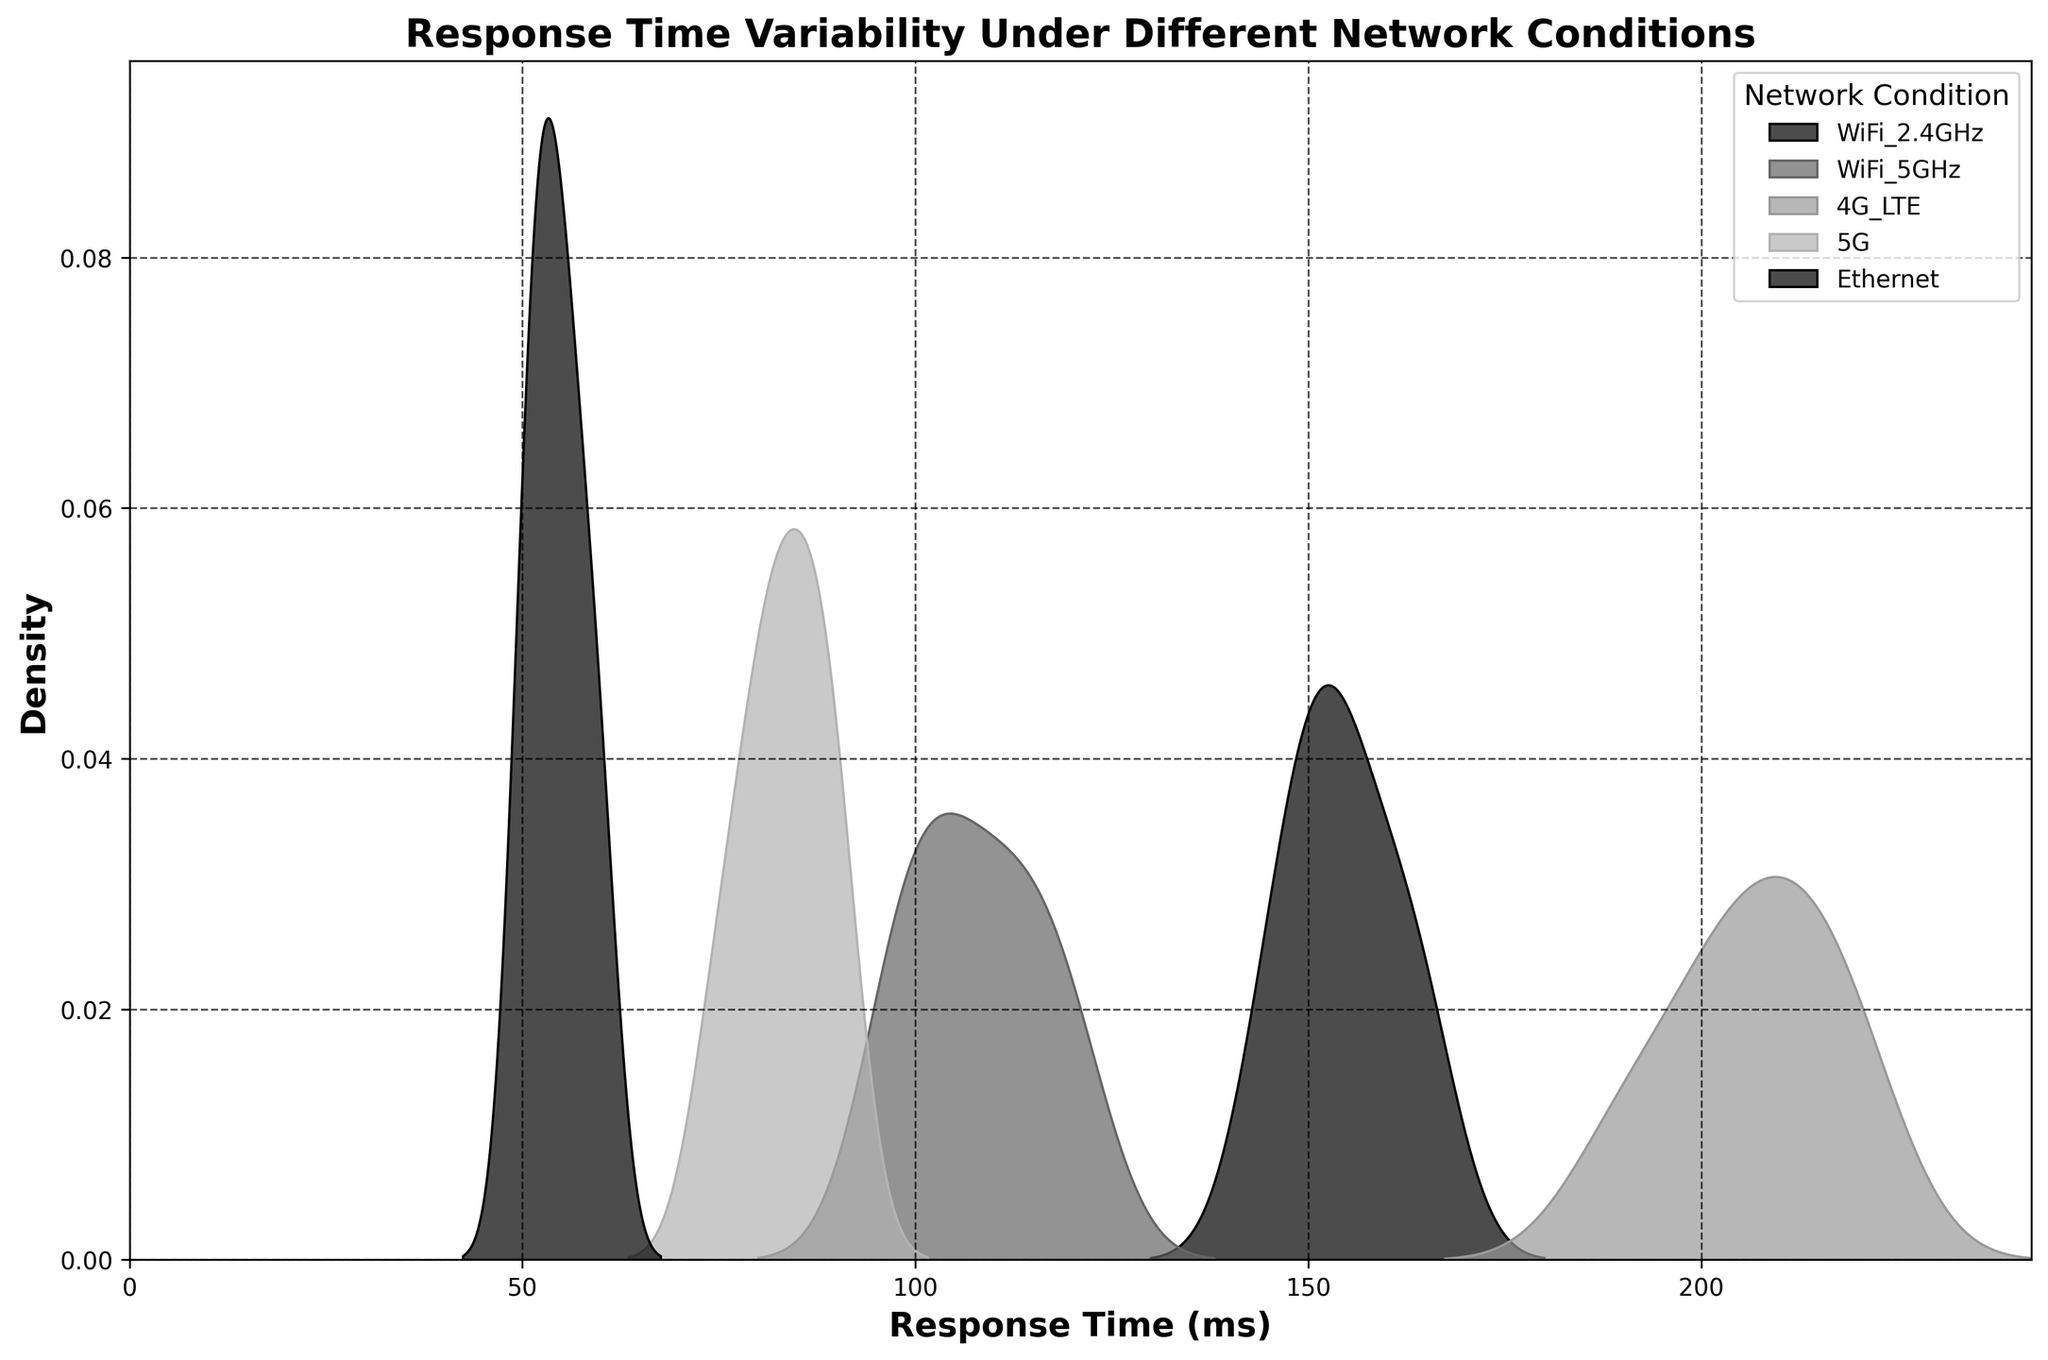What's the title of the figure? The title of the figure is located at the top, and it gives an overview of what the plot is about. By reading it, we learn that it is observing response time variability under different network conditions.
Answer: Response Time Variability Under Different Network Conditions What is the unit for the x-axis? The x-axis label indicates the unit of measure for response time, which is clearly stated in parentheses after the label name.
Answer: ms (milliseconds) Which network condition has the highest peak density? By observing the peaks of the density curves, you can identify that the highest peak density is depicted by the curve that reaches the highest value on the y-axis.
Answer: 5G What is the approximate range of response time values for Ethernet? Looking at the density curve for Ethernet, you identify the spread along the x-axis where this curve shows density. Ethernet has values around 50 to 60 ms.
Answer: 50 to 60 ms Is there any network condition with a response time density higher than 250 ms? Check the x-axis range and ensure none of the density lines extend beyond this value. All curves should be below this threshold based on the plot’s boundaries.
Answer: No Which network condition has the lowest variability in response times? The network condition with the narrowest peak (most concentrated) density curve has the lowest variability. This can be identified by observing which curve has the smallest spread.
Answer: Ethernet How many unique network conditions are compared in the plot? Count the number of unique labels in the legend to determine how many different network conditions were analyzed.
Answer: 5 Compare the response time ranges between WiFi 2.4GHz and WiFi 5GHz. Which one has a wider range? To determine the range, observe the spread of the density curves along the x-axis for both WiFi 2.4GHz and WiFi 5GHz and compare which one covers a broader range of milliseconds.
Answer: WiFi 2.4GHz What is the x-axis limit set for the plot? The x-axis limit can be identified by looking at the numerical range defined on the horizontal axis, starting from the minimum to the maximum value.
Answer: 0 to 242 ms Which network condition likely has the most stable connection based on the response time distribution? The most stable connection would be indicated by the network condition having the narrowest and highest density peak, suggesting consistent response times.
Answer: Ethernet 